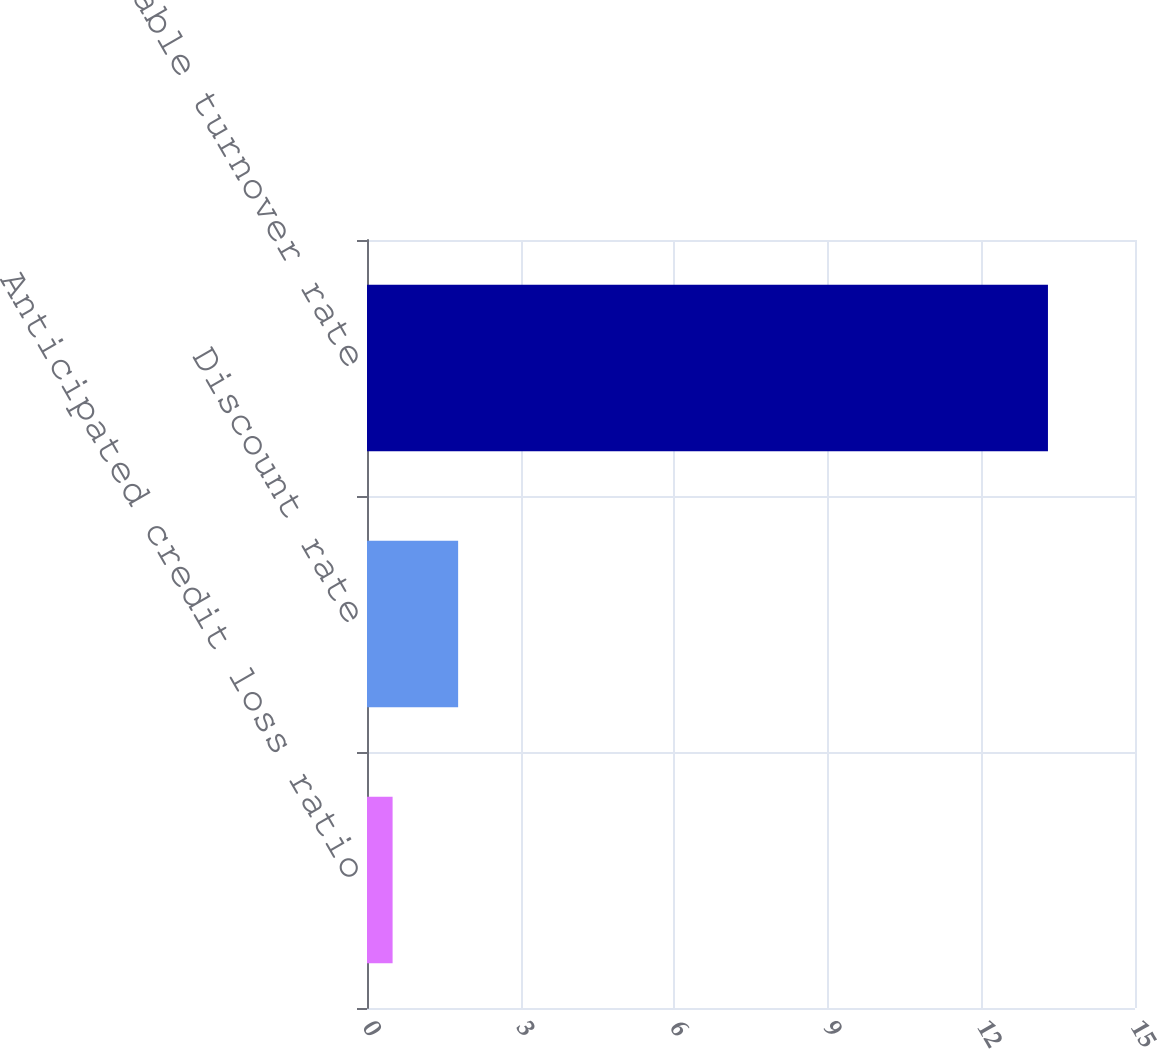Convert chart. <chart><loc_0><loc_0><loc_500><loc_500><bar_chart><fcel>Anticipated credit loss ratio<fcel>Discount rate<fcel>Receivable turnover rate<nl><fcel>0.5<fcel>1.78<fcel>13.3<nl></chart> 